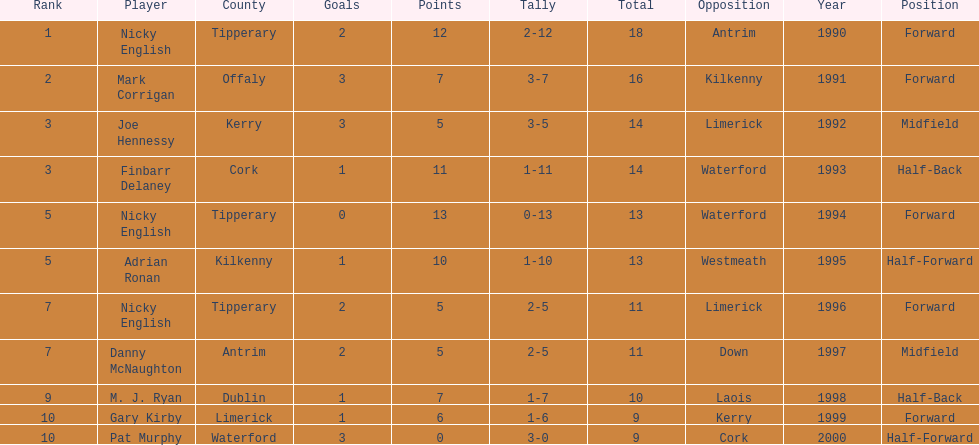What player got 10 total points in their game? M. J. Ryan. 